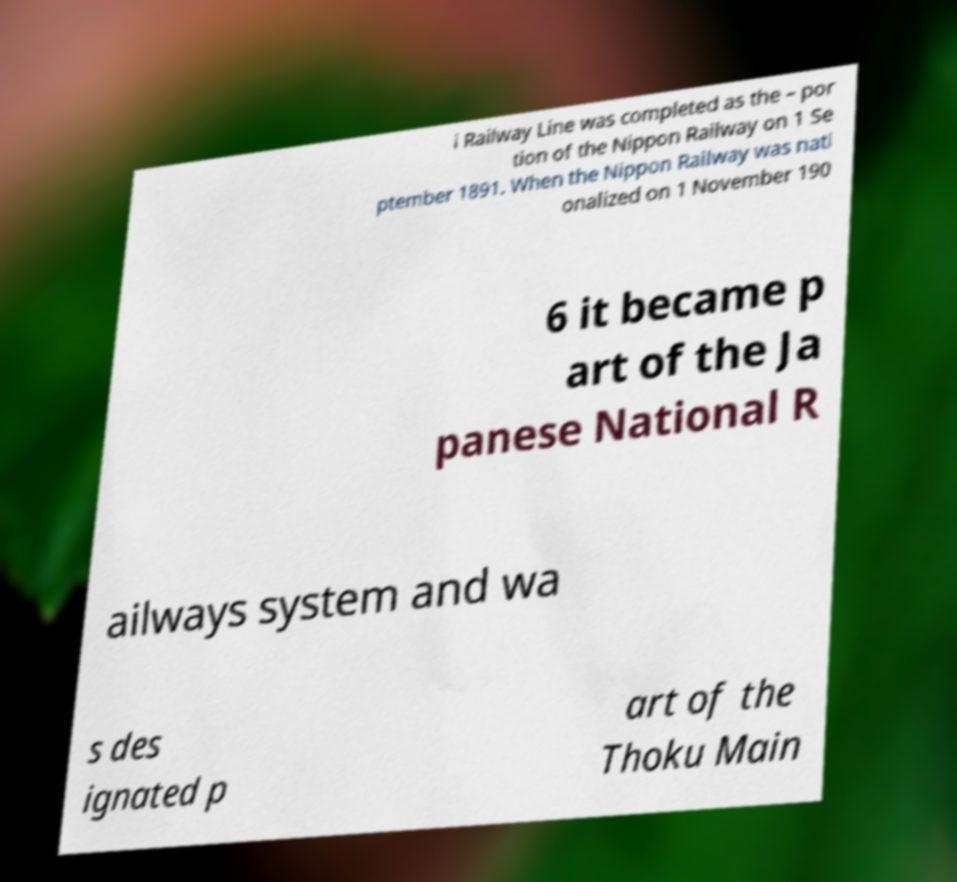I need the written content from this picture converted into text. Can you do that? i Railway Line was completed as the – por tion of the Nippon Railway on 1 Se ptember 1891. When the Nippon Railway was nati onalized on 1 November 190 6 it became p art of the Ja panese National R ailways system and wa s des ignated p art of the Thoku Main 